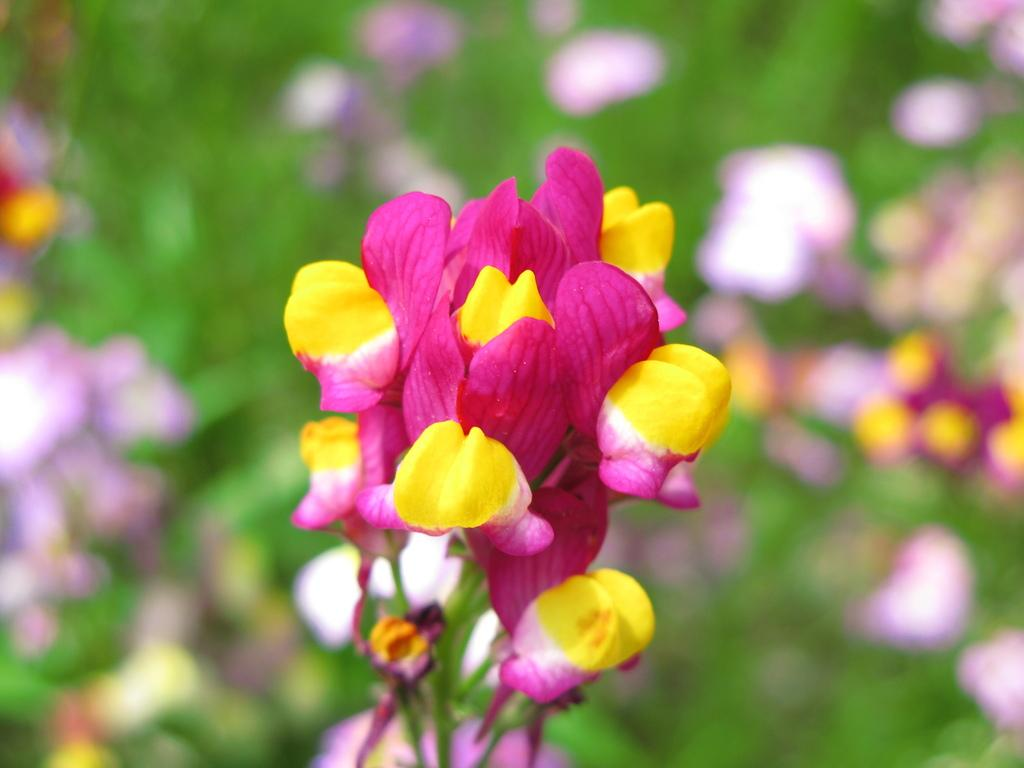What colors of flowers can be seen in the image? There are pink and yellow flowers in the image. Can you describe the background of the image? The background of the image is blurry. What country is depicted in the background of the image? There is no country depicted in the image, as the background is blurry and does not show any recognizable landmarks or geographical features. Can you hear thunder in the image? There is no sound in the image, so it is not possible to determine if thunder can be heard. 